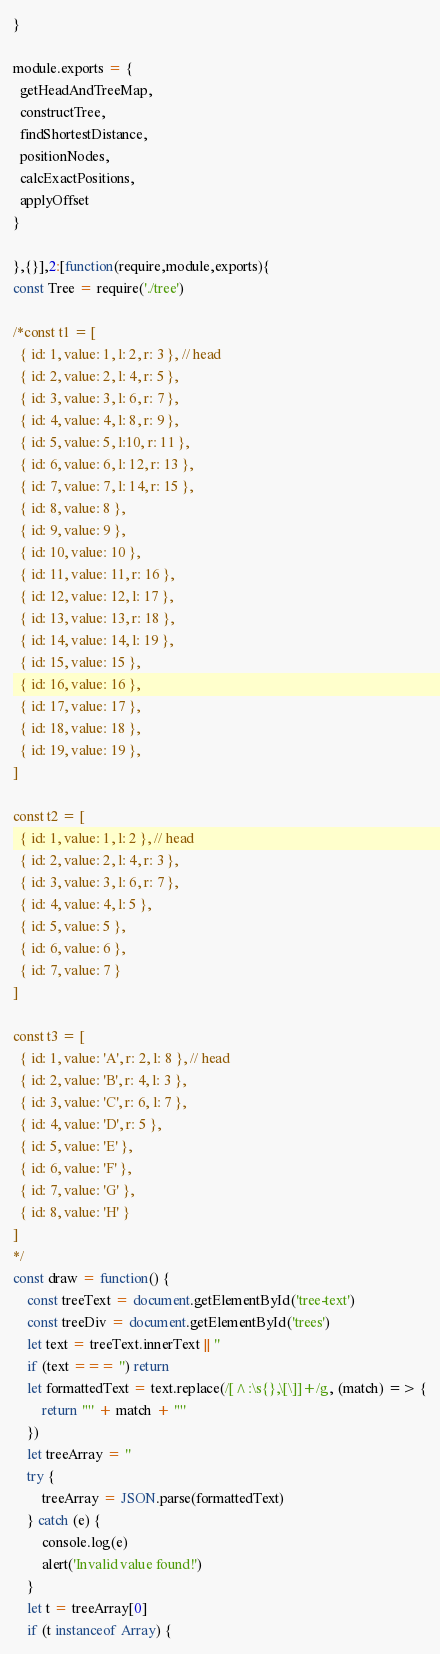<code> <loc_0><loc_0><loc_500><loc_500><_JavaScript_>}

module.exports = {
  getHeadAndTreeMap,
  constructTree,
  findShortestDistance,
  positionNodes,
  calcExactPositions,
  applyOffset
}

},{}],2:[function(require,module,exports){
const Tree = require('./tree')

/*const t1 = [
  { id: 1, value: 1, l: 2, r: 3 }, // head
  { id: 2, value: 2, l: 4, r: 5 },
  { id: 3, value: 3, l: 6, r: 7 },
  { id: 4, value: 4, l: 8, r: 9 },
  { id: 5, value: 5, l:10, r: 11 },
  { id: 6, value: 6, l: 12, r: 13 },
  { id: 7, value: 7, l: 14, r: 15 },
  { id: 8, value: 8 },
  { id: 9, value: 9 },
  { id: 10, value: 10 },
  { id: 11, value: 11, r: 16 },
  { id: 12, value: 12, l: 17 },
  { id: 13, value: 13, r: 18 },
  { id: 14, value: 14, l: 19 },
  { id: 15, value: 15 },
  { id: 16, value: 16 },
  { id: 17, value: 17 },
  { id: 18, value: 18 },
  { id: 19, value: 19 },
]

const t2 = [
  { id: 1, value: 1, l: 2 }, // head
  { id: 2, value: 2, l: 4, r: 3 },
  { id: 3, value: 3, l: 6, r: 7 },
  { id: 4, value: 4, l: 5 },
  { id: 5, value: 5 },
  { id: 6, value: 6 },
  { id: 7, value: 7 }
]

const t3 = [
  { id: 1, value: 'A', r: 2, l: 8 }, // head
  { id: 2, value: 'B', r: 4, l: 3 },
  { id: 3, value: 'C', r: 6, l: 7 },
  { id: 4, value: 'D', r: 5 },
  { id: 5, value: 'E' },
  { id: 6, value: 'F' },
  { id: 7, value: 'G' },
  { id: 8, value: 'H' }
]
*/
const draw = function() {
    const treeText = document.getElementById('tree-text')
    const treeDiv = document.getElementById('trees')
    let text = treeText.innerText || ''
    if (text === '') return
    let formattedText = text.replace(/[^:\s{},\[\]]+/g, (match) => {
        return '"' + match + '"'
    })
    let treeArray = ''
    try {
        treeArray = JSON.parse(formattedText)
    } catch (e) {
        console.log(e)
        alert('Invalid value found!')
    }
    let t = treeArray[0]
    if (t instanceof Array) {</code> 